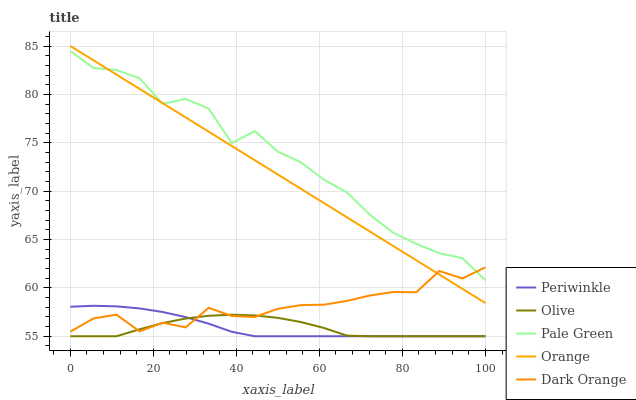Does Orange have the minimum area under the curve?
Answer yes or no. No. Does Orange have the maximum area under the curve?
Answer yes or no. No. Is Pale Green the smoothest?
Answer yes or no. No. Is Orange the roughest?
Answer yes or no. No. Does Orange have the lowest value?
Answer yes or no. No. Does Pale Green have the highest value?
Answer yes or no. No. Is Periwinkle less than Pale Green?
Answer yes or no. Yes. Is Pale Green greater than Olive?
Answer yes or no. Yes. Does Periwinkle intersect Pale Green?
Answer yes or no. No. 